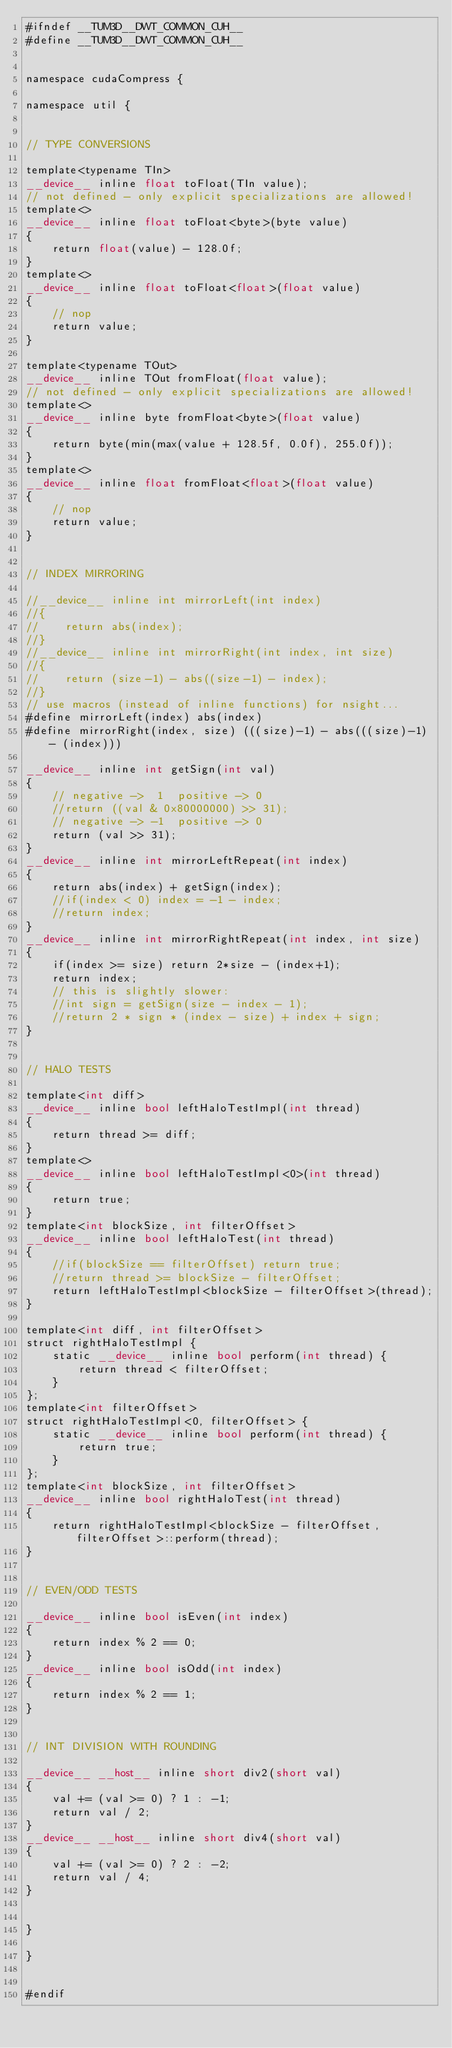Convert code to text. <code><loc_0><loc_0><loc_500><loc_500><_Cuda_>#ifndef __TUM3D__DWT_COMMON_CUH__
#define __TUM3D__DWT_COMMON_CUH__


namespace cudaCompress {

namespace util {


// TYPE CONVERSIONS

template<typename TIn>
__device__ inline float toFloat(TIn value);
// not defined - only explicit specializations are allowed!
template<>
__device__ inline float toFloat<byte>(byte value)
{
    return float(value) - 128.0f;
}
template<>
__device__ inline float toFloat<float>(float value)
{
    // nop
    return value;
}

template<typename TOut>
__device__ inline TOut fromFloat(float value);
// not defined - only explicit specializations are allowed!
template<>
__device__ inline byte fromFloat<byte>(float value)
{
    return byte(min(max(value + 128.5f, 0.0f), 255.0f));
}
template<>
__device__ inline float fromFloat<float>(float value)
{
    // nop
    return value;
}


// INDEX MIRRORING

//__device__ inline int mirrorLeft(int index)
//{
//    return abs(index);
//}
//__device__ inline int mirrorRight(int index, int size)
//{
//    return (size-1) - abs((size-1) - index);
//}
// use macros (instead of inline functions) for nsight...
#define mirrorLeft(index) abs(index)
#define mirrorRight(index, size) (((size)-1) - abs(((size)-1) - (index)))

__device__ inline int getSign(int val)
{
    // negative ->  1  positive -> 0
    //return ((val & 0x80000000) >> 31);
    // negative -> -1  positive -> 0
    return (val >> 31);
}
__device__ inline int mirrorLeftRepeat(int index)
{
    return abs(index) + getSign(index);
    //if(index < 0) index = -1 - index;
    //return index;
}
__device__ inline int mirrorRightRepeat(int index, int size)
{
    if(index >= size) return 2*size - (index+1);
    return index;
    // this is slightly slower:
    //int sign = getSign(size - index - 1);
    //return 2 * sign * (index - size) + index + sign;
}


// HALO TESTS

template<int diff>
__device__ inline bool leftHaloTestImpl(int thread)
{
    return thread >= diff;
}
template<>
__device__ inline bool leftHaloTestImpl<0>(int thread)
{
    return true;
}
template<int blockSize, int filterOffset>
__device__ inline bool leftHaloTest(int thread)
{
    //if(blockSize == filterOffset) return true;
    //return thread >= blockSize - filterOffset;
    return leftHaloTestImpl<blockSize - filterOffset>(thread);
}

template<int diff, int filterOffset>
struct rightHaloTestImpl {
    static __device__ inline bool perform(int thread) {
        return thread < filterOffset;
    }
};
template<int filterOffset>
struct rightHaloTestImpl<0, filterOffset> {
    static __device__ inline bool perform(int thread) {
        return true;
    }
};
template<int blockSize, int filterOffset>
__device__ inline bool rightHaloTest(int thread)
{
    return rightHaloTestImpl<blockSize - filterOffset, filterOffset>::perform(thread);
}


// EVEN/ODD TESTS

__device__ inline bool isEven(int index)
{
    return index % 2 == 0;
}
__device__ inline bool isOdd(int index)
{
    return index % 2 == 1;
}


// INT DIVISION WITH ROUNDING

__device__ __host__ inline short div2(short val)
{
    val += (val >= 0) ? 1 : -1;
    return val / 2;
}
__device__ __host__ inline short div4(short val)
{
    val += (val >= 0) ? 2 : -2;
    return val / 4;
}


}

}


#endif
</code> 